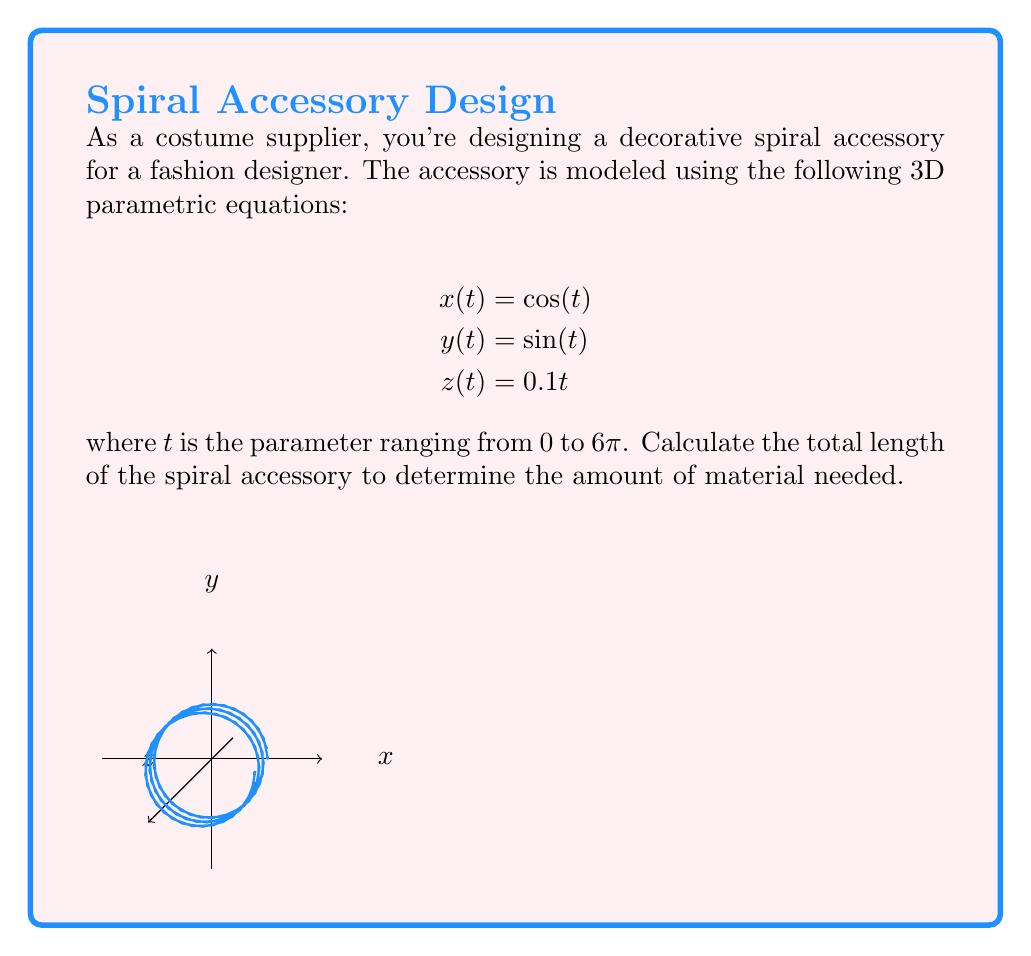Solve this math problem. To find the length of the spiral, we need to calculate the arc length using the following steps:

1) The arc length formula for a 3D parametric curve is:

   $$L = \int_{a}^{b} \sqrt{\left(\frac{dx}{dt}\right)^2 + \left(\frac{dy}{dt}\right)^2 + \left(\frac{dz}{dt}\right)^2} dt$$

2) Calculate the derivatives:
   $$\frac{dx}{dt} = -\sin(t)$$
   $$\frac{dy}{dt} = \cos(t)$$
   $$\frac{dz}{dt} = 0.1$$

3) Substitute these into the arc length formula:

   $$L = \int_{0}^{6\pi} \sqrt{(-\sin(t))^2 + (\cos(t))^2 + (0.1)^2} dt$$

4) Simplify under the square root:
   $$L = \int_{0}^{6\pi} \sqrt{\sin^2(t) + \cos^2(t) + 0.01} dt$$

5) Use the trigonometric identity $\sin^2(t) + \cos^2(t) = 1$:
   $$L = \int_{0}^{6\pi} \sqrt{1 + 0.01} dt = \int_{0}^{6\pi} \sqrt{1.01} dt$$

6) $\sqrt{1.01}$ is a constant, so we can take it out of the integral:
   $$L = \sqrt{1.01} \int_{0}^{6\pi} dt$$

7) Evaluate the integral:
   $$L = \sqrt{1.01} [t]_{0}^{6\pi} = \sqrt{1.01} (6\pi - 0) = 6\pi\sqrt{1.01}$$

8) Calculate the final value:
   $$L \approx 18.91$$

Therefore, the total length of the spiral accessory is approximately 18.91 units.
Answer: $6\pi\sqrt{1.01} \approx 18.91$ units 